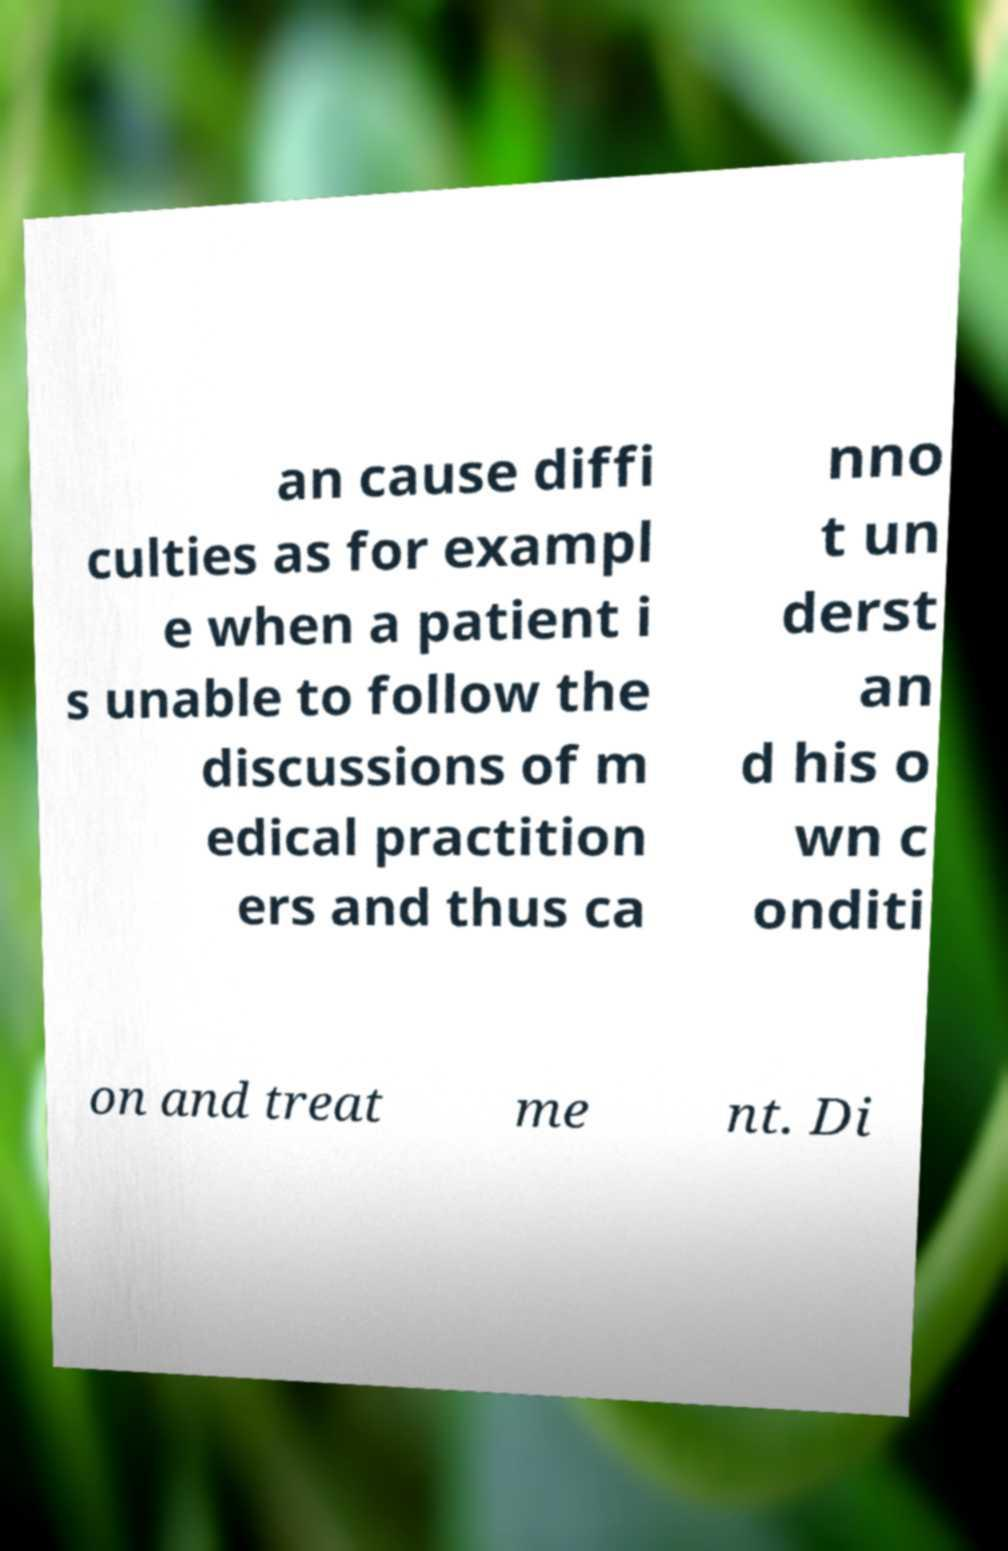Can you read and provide the text displayed in the image?This photo seems to have some interesting text. Can you extract and type it out for me? an cause diffi culties as for exampl e when a patient i s unable to follow the discussions of m edical practition ers and thus ca nno t un derst an d his o wn c onditi on and treat me nt. Di 